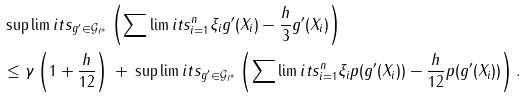Convert formula to latex. <formula><loc_0><loc_0><loc_500><loc_500>& \sup \lim i t s _ { g ^ { \prime } \in \mathcal { G } _ { f ^ { * } } } \left ( \sum \lim i t s _ { i = 1 } ^ { n } \xi _ { i } g ^ { \prime } ( X _ { i } ) - \frac { h } { 3 } g ^ { \prime } ( X _ { i } ) \right ) \\ & \leq \gamma \left ( 1 + \frac { h } { 1 2 } \right ) \, + \, \sup \lim i t s _ { g ^ { \prime } \in \mathcal { G } _ { f ^ { * } } } \left ( \sum \lim i t s _ { i = 1 } ^ { n } \xi _ { i } p ( g ^ { \prime } ( X _ { i } ) ) - \frac { h } { 1 2 } p ( g ^ { \prime } ( X _ { i } ) ) \right ) .</formula> 